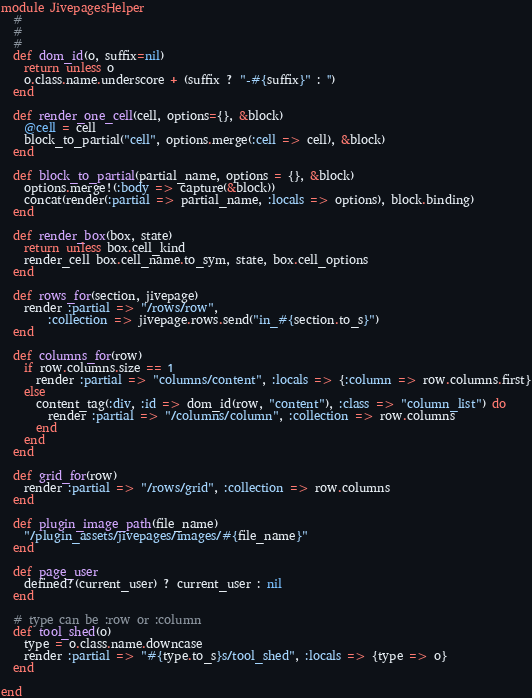Convert code to text. <code><loc_0><loc_0><loc_500><loc_500><_Ruby_>module JivepagesHelper
  #
  #
  #
  def dom_id(o, suffix=nil)
    return unless o     
    o.class.name.underscore + (suffix ? "-#{suffix}" : '')    
  end
  
  def render_one_cell(cell, options={}, &block)   
    @cell = cell
    block_to_partial("cell", options.merge(:cell => cell), &block)    
  end
  
  def block_to_partial(partial_name, options = {}, &block)
    options.merge!(:body => capture(&block))
    concat(render(:partial => partial_name, :locals => options), block.binding)
  end
  
  def render_box(box, state)
    return unless box.cell_kind
    render_cell box.cell_name.to_sym, state, box.cell_options
  end
  
  def rows_for(section, jivepage)
    render :partial => "/rows/row", 
        :collection => jivepage.rows.send("in_#{section.to_s}")
  end
  
  def columns_for(row)
    if row.columns.size == 1
      render :partial => "columns/content", :locals => {:column => row.columns.first}
    else
      content_tag(:div, :id => dom_id(row, "content"), :class => "column_list") do
        render :partial => "/columns/column", :collection => row.columns
      end
    end
  end
  
  def grid_for(row)
    render :partial => "/rows/grid", :collection => row.columns
  end
  
  def plugin_image_path(file_name)
    "/plugin_assets/jivepages/images/#{file_name}"
  end
  
  def page_user
    defined?(current_user) ? current_user : nil
  end
  
  # type can be :row or :column
  def tool_shed(o)
    type = o.class.name.downcase
    render :partial => "#{type.to_s}s/tool_shed", :locals => {type => o}
  end

end
</code> 